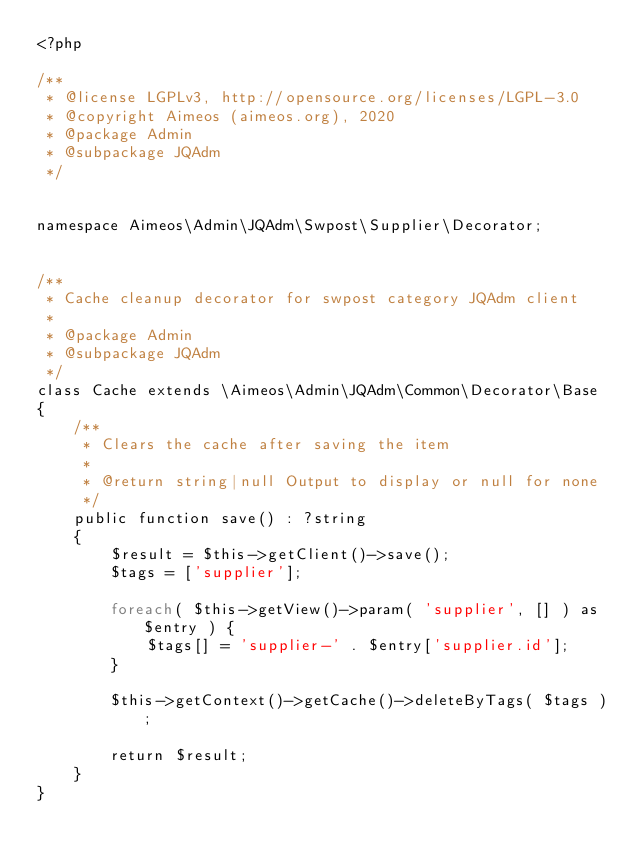Convert code to text. <code><loc_0><loc_0><loc_500><loc_500><_PHP_><?php

/**
 * @license LGPLv3, http://opensource.org/licenses/LGPL-3.0
 * @copyright Aimeos (aimeos.org), 2020
 * @package Admin
 * @subpackage JQAdm
 */


namespace Aimeos\Admin\JQAdm\Swpost\Supplier\Decorator;


/**
 * Cache cleanup decorator for swpost category JQAdm client
 *
 * @package Admin
 * @subpackage JQAdm
 */
class Cache extends \Aimeos\Admin\JQAdm\Common\Decorator\Base
{
	/**
	 * Clears the cache after saving the item
	 *
	 * @return string|null Output to display or null for none
	 */
	public function save() : ?string
	{
		$result = $this->getClient()->save();
		$tags = ['supplier'];

		foreach( $this->getView()->param( 'supplier', [] ) as $entry ) {
			$tags[] = 'supplier-' . $entry['supplier.id'];
		}

		$this->getContext()->getCache()->deleteByTags( $tags );

		return $result;
	}
}
</code> 